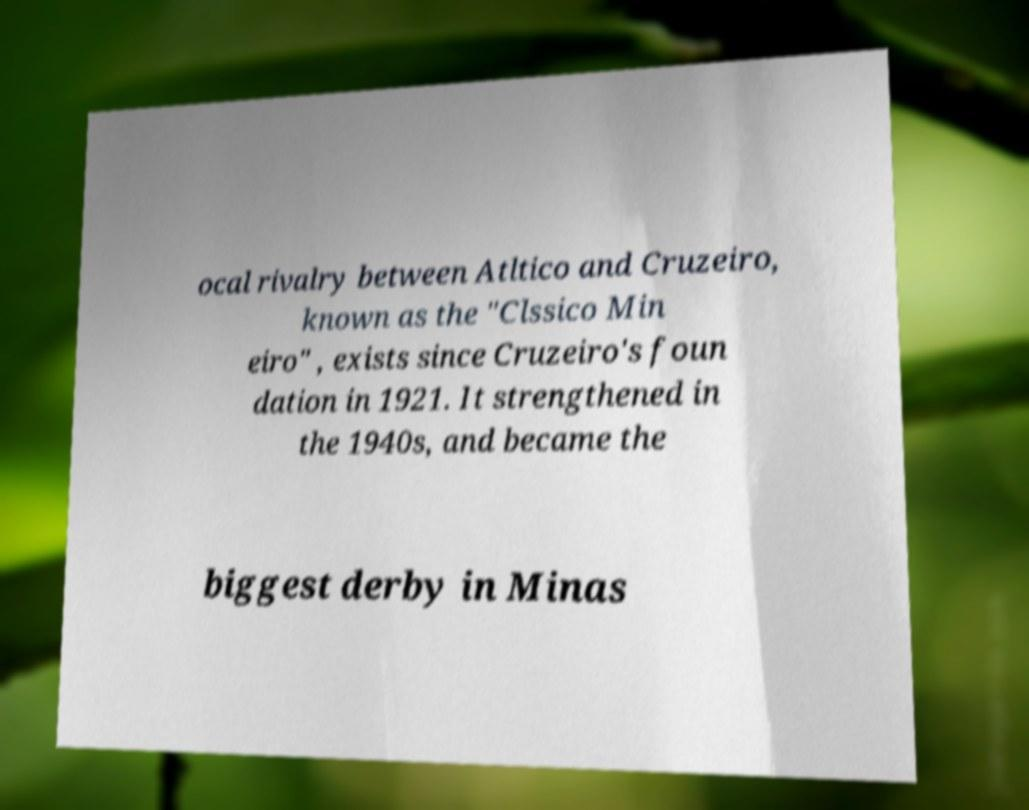Could you assist in decoding the text presented in this image and type it out clearly? ocal rivalry between Atltico and Cruzeiro, known as the "Clssico Min eiro" , exists since Cruzeiro's foun dation in 1921. It strengthened in the 1940s, and became the biggest derby in Minas 